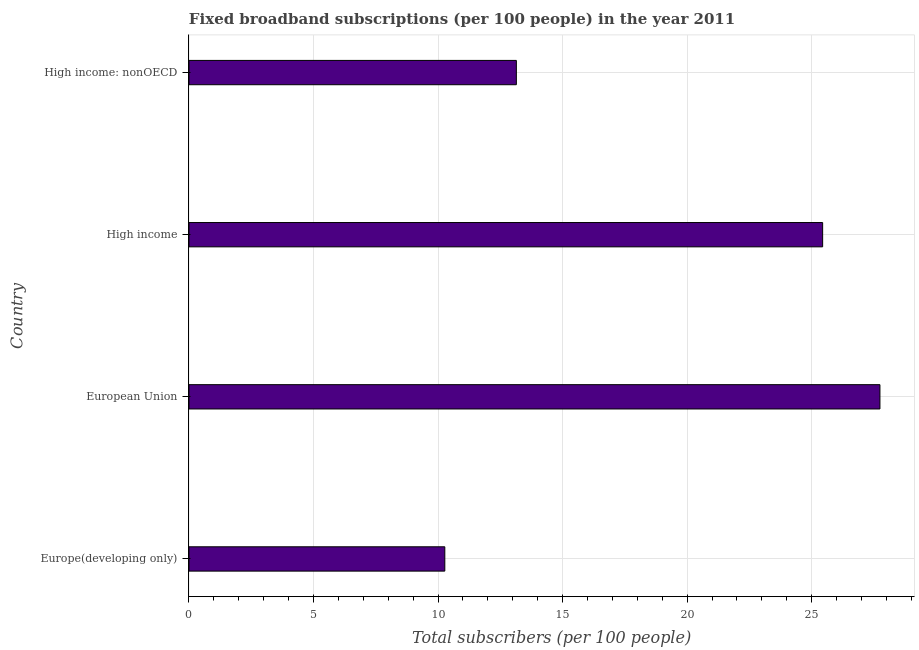Does the graph contain any zero values?
Provide a succinct answer. No. What is the title of the graph?
Your answer should be very brief. Fixed broadband subscriptions (per 100 people) in the year 2011. What is the label or title of the X-axis?
Offer a terse response. Total subscribers (per 100 people). What is the total number of fixed broadband subscriptions in High income: nonOECD?
Provide a short and direct response. 13.14. Across all countries, what is the maximum total number of fixed broadband subscriptions?
Offer a terse response. 27.74. Across all countries, what is the minimum total number of fixed broadband subscriptions?
Your answer should be very brief. 10.27. In which country was the total number of fixed broadband subscriptions maximum?
Offer a very short reply. European Union. In which country was the total number of fixed broadband subscriptions minimum?
Provide a short and direct response. Europe(developing only). What is the sum of the total number of fixed broadband subscriptions?
Give a very brief answer. 76.6. What is the difference between the total number of fixed broadband subscriptions in High income and High income: nonOECD?
Offer a very short reply. 12.3. What is the average total number of fixed broadband subscriptions per country?
Make the answer very short. 19.15. What is the median total number of fixed broadband subscriptions?
Ensure brevity in your answer.  19.29. In how many countries, is the total number of fixed broadband subscriptions greater than 10 ?
Your answer should be compact. 4. What is the ratio of the total number of fixed broadband subscriptions in Europe(developing only) to that in European Union?
Offer a very short reply. 0.37. Is the total number of fixed broadband subscriptions in European Union less than that in High income: nonOECD?
Your answer should be compact. No. Is the difference between the total number of fixed broadband subscriptions in Europe(developing only) and High income greater than the difference between any two countries?
Provide a succinct answer. No. What is the difference between the highest and the lowest total number of fixed broadband subscriptions?
Give a very brief answer. 17.47. In how many countries, is the total number of fixed broadband subscriptions greater than the average total number of fixed broadband subscriptions taken over all countries?
Provide a succinct answer. 2. What is the difference between two consecutive major ticks on the X-axis?
Provide a short and direct response. 5. Are the values on the major ticks of X-axis written in scientific E-notation?
Provide a short and direct response. No. What is the Total subscribers (per 100 people) in Europe(developing only)?
Make the answer very short. 10.27. What is the Total subscribers (per 100 people) of European Union?
Your response must be concise. 27.74. What is the Total subscribers (per 100 people) in High income?
Your answer should be very brief. 25.44. What is the Total subscribers (per 100 people) of High income: nonOECD?
Offer a terse response. 13.14. What is the difference between the Total subscribers (per 100 people) in Europe(developing only) and European Union?
Provide a short and direct response. -17.47. What is the difference between the Total subscribers (per 100 people) in Europe(developing only) and High income?
Offer a very short reply. -15.17. What is the difference between the Total subscribers (per 100 people) in Europe(developing only) and High income: nonOECD?
Make the answer very short. -2.87. What is the difference between the Total subscribers (per 100 people) in European Union and High income?
Keep it short and to the point. 2.3. What is the difference between the Total subscribers (per 100 people) in European Union and High income: nonOECD?
Keep it short and to the point. 14.6. What is the difference between the Total subscribers (per 100 people) in High income and High income: nonOECD?
Your response must be concise. 12.3. What is the ratio of the Total subscribers (per 100 people) in Europe(developing only) to that in European Union?
Provide a succinct answer. 0.37. What is the ratio of the Total subscribers (per 100 people) in Europe(developing only) to that in High income?
Your answer should be very brief. 0.4. What is the ratio of the Total subscribers (per 100 people) in Europe(developing only) to that in High income: nonOECD?
Ensure brevity in your answer.  0.78. What is the ratio of the Total subscribers (per 100 people) in European Union to that in High income?
Make the answer very short. 1.09. What is the ratio of the Total subscribers (per 100 people) in European Union to that in High income: nonOECD?
Provide a succinct answer. 2.11. What is the ratio of the Total subscribers (per 100 people) in High income to that in High income: nonOECD?
Give a very brief answer. 1.94. 